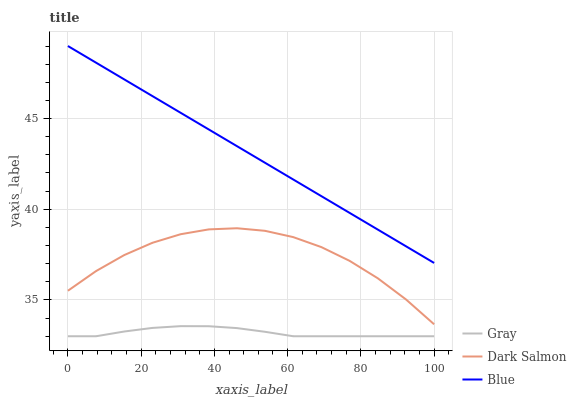Does Gray have the minimum area under the curve?
Answer yes or no. Yes. Does Blue have the maximum area under the curve?
Answer yes or no. Yes. Does Dark Salmon have the minimum area under the curve?
Answer yes or no. No. Does Dark Salmon have the maximum area under the curve?
Answer yes or no. No. Is Blue the smoothest?
Answer yes or no. Yes. Is Dark Salmon the roughest?
Answer yes or no. Yes. Is Gray the smoothest?
Answer yes or no. No. Is Gray the roughest?
Answer yes or no. No. Does Gray have the lowest value?
Answer yes or no. Yes. Does Dark Salmon have the lowest value?
Answer yes or no. No. Does Blue have the highest value?
Answer yes or no. Yes. Does Dark Salmon have the highest value?
Answer yes or no. No. Is Dark Salmon less than Blue?
Answer yes or no. Yes. Is Blue greater than Gray?
Answer yes or no. Yes. Does Dark Salmon intersect Blue?
Answer yes or no. No. 